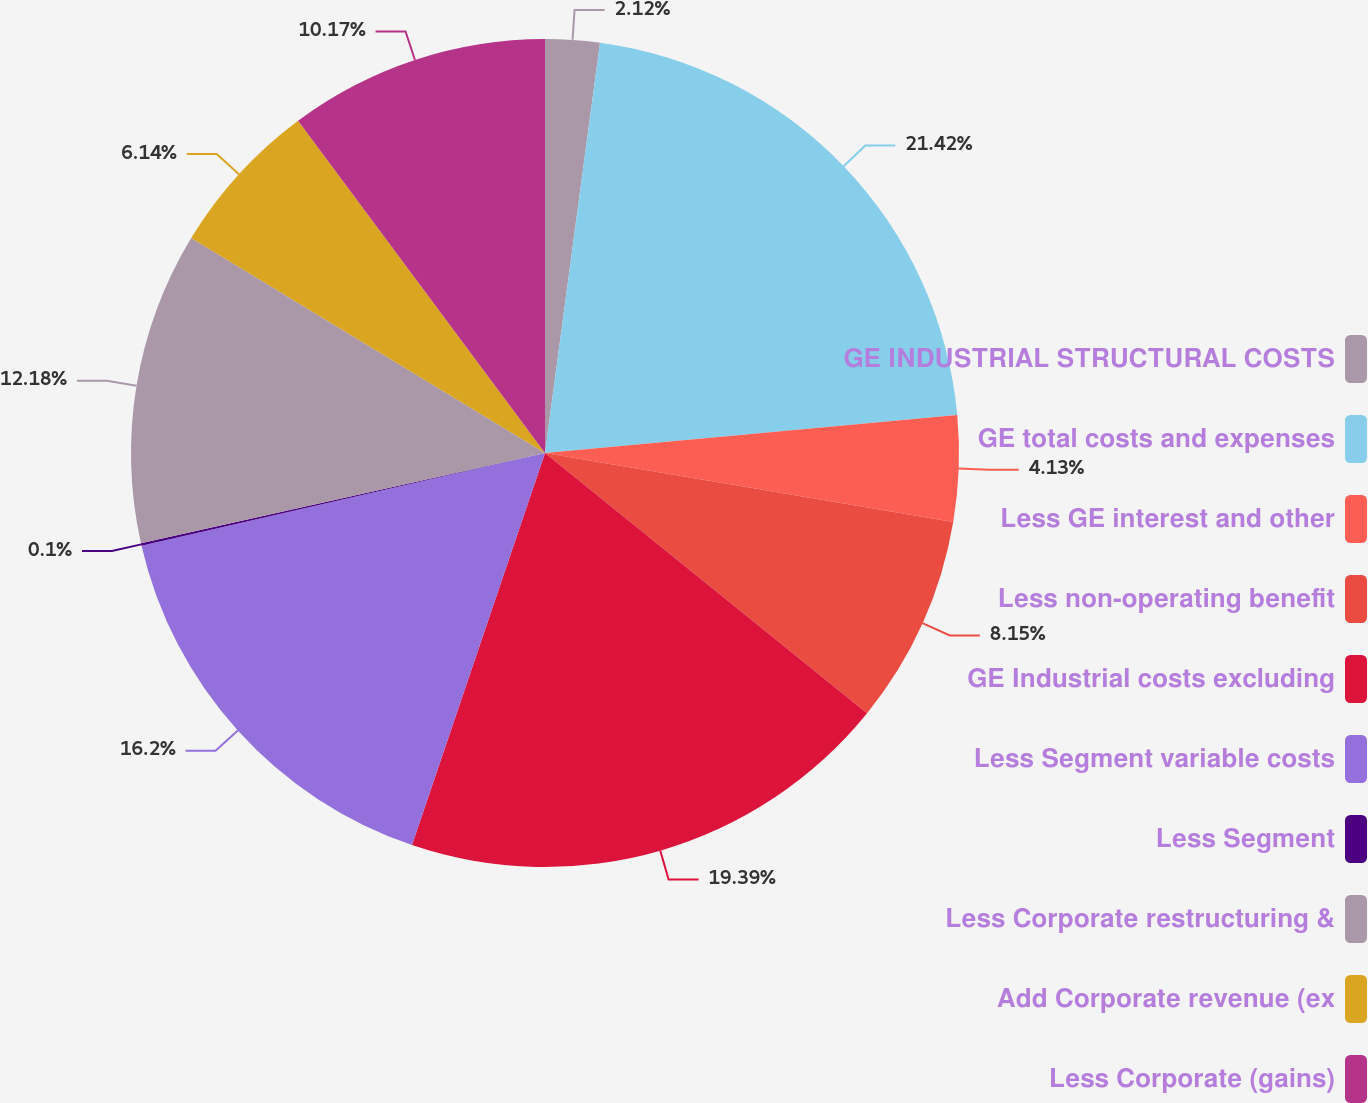Convert chart to OTSL. <chart><loc_0><loc_0><loc_500><loc_500><pie_chart><fcel>GE INDUSTRIAL STRUCTURAL COSTS<fcel>GE total costs and expenses<fcel>Less GE interest and other<fcel>Less non-operating benefit<fcel>GE Industrial costs excluding<fcel>Less Segment variable costs<fcel>Less Segment<fcel>Less Corporate restructuring &<fcel>Add Corporate revenue (ex<fcel>Less Corporate (gains)<nl><fcel>2.12%<fcel>21.41%<fcel>4.13%<fcel>8.15%<fcel>19.39%<fcel>16.2%<fcel>0.1%<fcel>12.18%<fcel>6.14%<fcel>10.17%<nl></chart> 